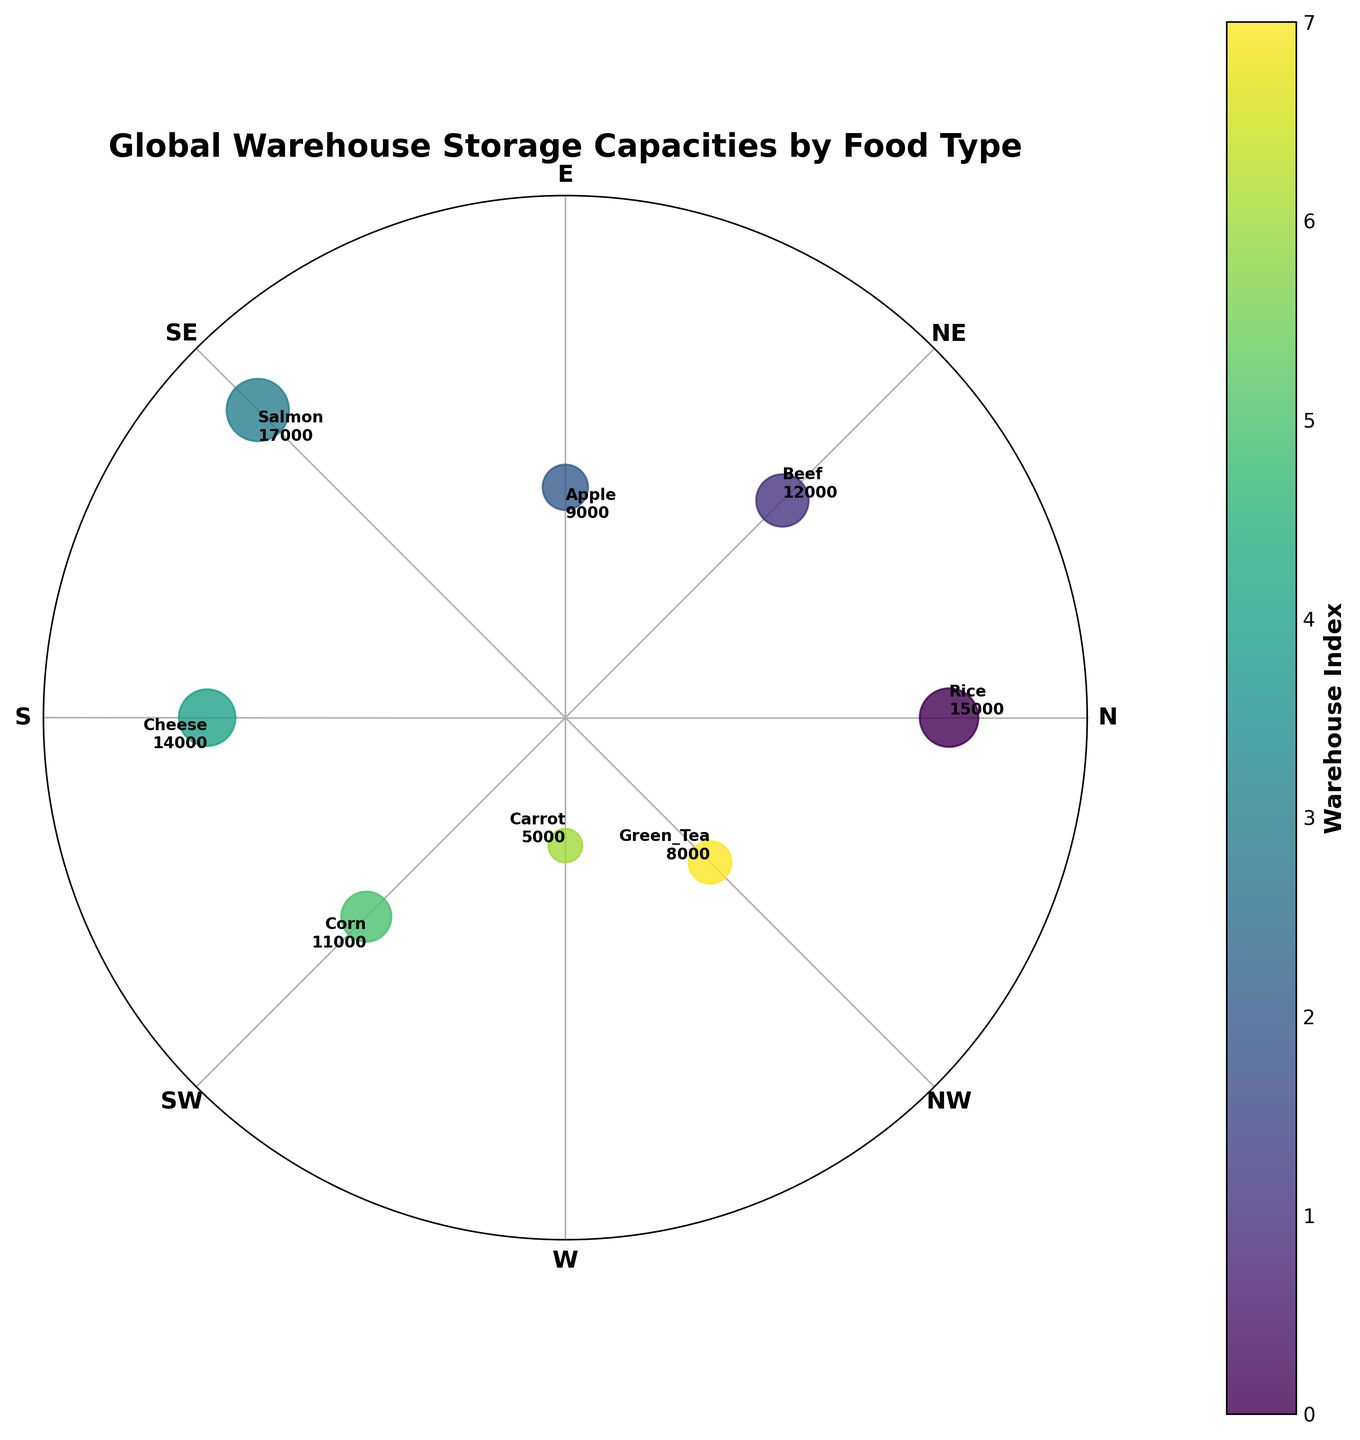what is the title of the plot? The title is the text located at the top of the plot, which summarizes the main purpose or content of the visual representation.
Answer: Global Warehouse Storage Capacities by Food Type What is the food type with the largest storage capacity? The largest storage capacity point will be the farthest from the center of the plot (i.e., the furthest point on the radius) and the annotations can be checked to identify the food type.
Answer: Salmon Which direction corresponds to the warehouse with the smallest storage capacity? The warehouse with the smallest storage capacity is represented by the point closest to the center of the plot and its angle annotation.
Answer: West What is the approximate color associated with the warehouse in Europe distributing carrots? Locate the warehouse in Europe distributing carrots from the annotations and determine its color on the color bar.
Answer: Light Violet Which region has the most diverse types of food stored (i.e., represented by the greatest number of food types)? By analyzing the annotations and labels for each direction/angle, check which region has most different food types listed.
Answer: Asia What are the average storage capacities of warehouses in Europe? Identify the European warehouses (Apple in Spain and Carrot in France) from the annotations, sum their storage capacities, and divide by the number of warehouses.
Answer: (9000 + 5000) / 2 = 7000 How does the storage capacity of dairy (Cheese) in Oceania compare to the storage capacity of rice in North America? Locate both the dairy (Cheese) point and rice point on the plot, then compare their distances from the center of the plot (their storage capacities).
Answer: Cheese has 14000, which is less than Rice's 15000 What food type stored in Africa has the highest storage capacity according to the plot? Identify the point for Africa (Corn at 225 degrees) and check its associated storage capacity.
Answer: Corn If you categorize the food types into two groups: meat (Beef, Salmon) and plant-based (Rice, Apple, Corn, Carrot, Green Tea, Cheese), which group has a higher average storage capacity? Sum the storage capacities for meat and plant-based categories separately, then calculate and compare the averages of the two groups.
Answer: Meat: (12000 + 17000) / 2 = 14500; Plant-based: (15000 + 9000 + 11000 + 5000 + 8000 + 14000) / 6 ≈ 10333.33; Meat has a higher average Which warehouse has a higher storage capacity: the one storing green tea in China or the one storing corn in Nigeria? Identify the storage capacities for green tea (8000) and corn (11000) from the plot annotations and compare them.
Answer: Corn 